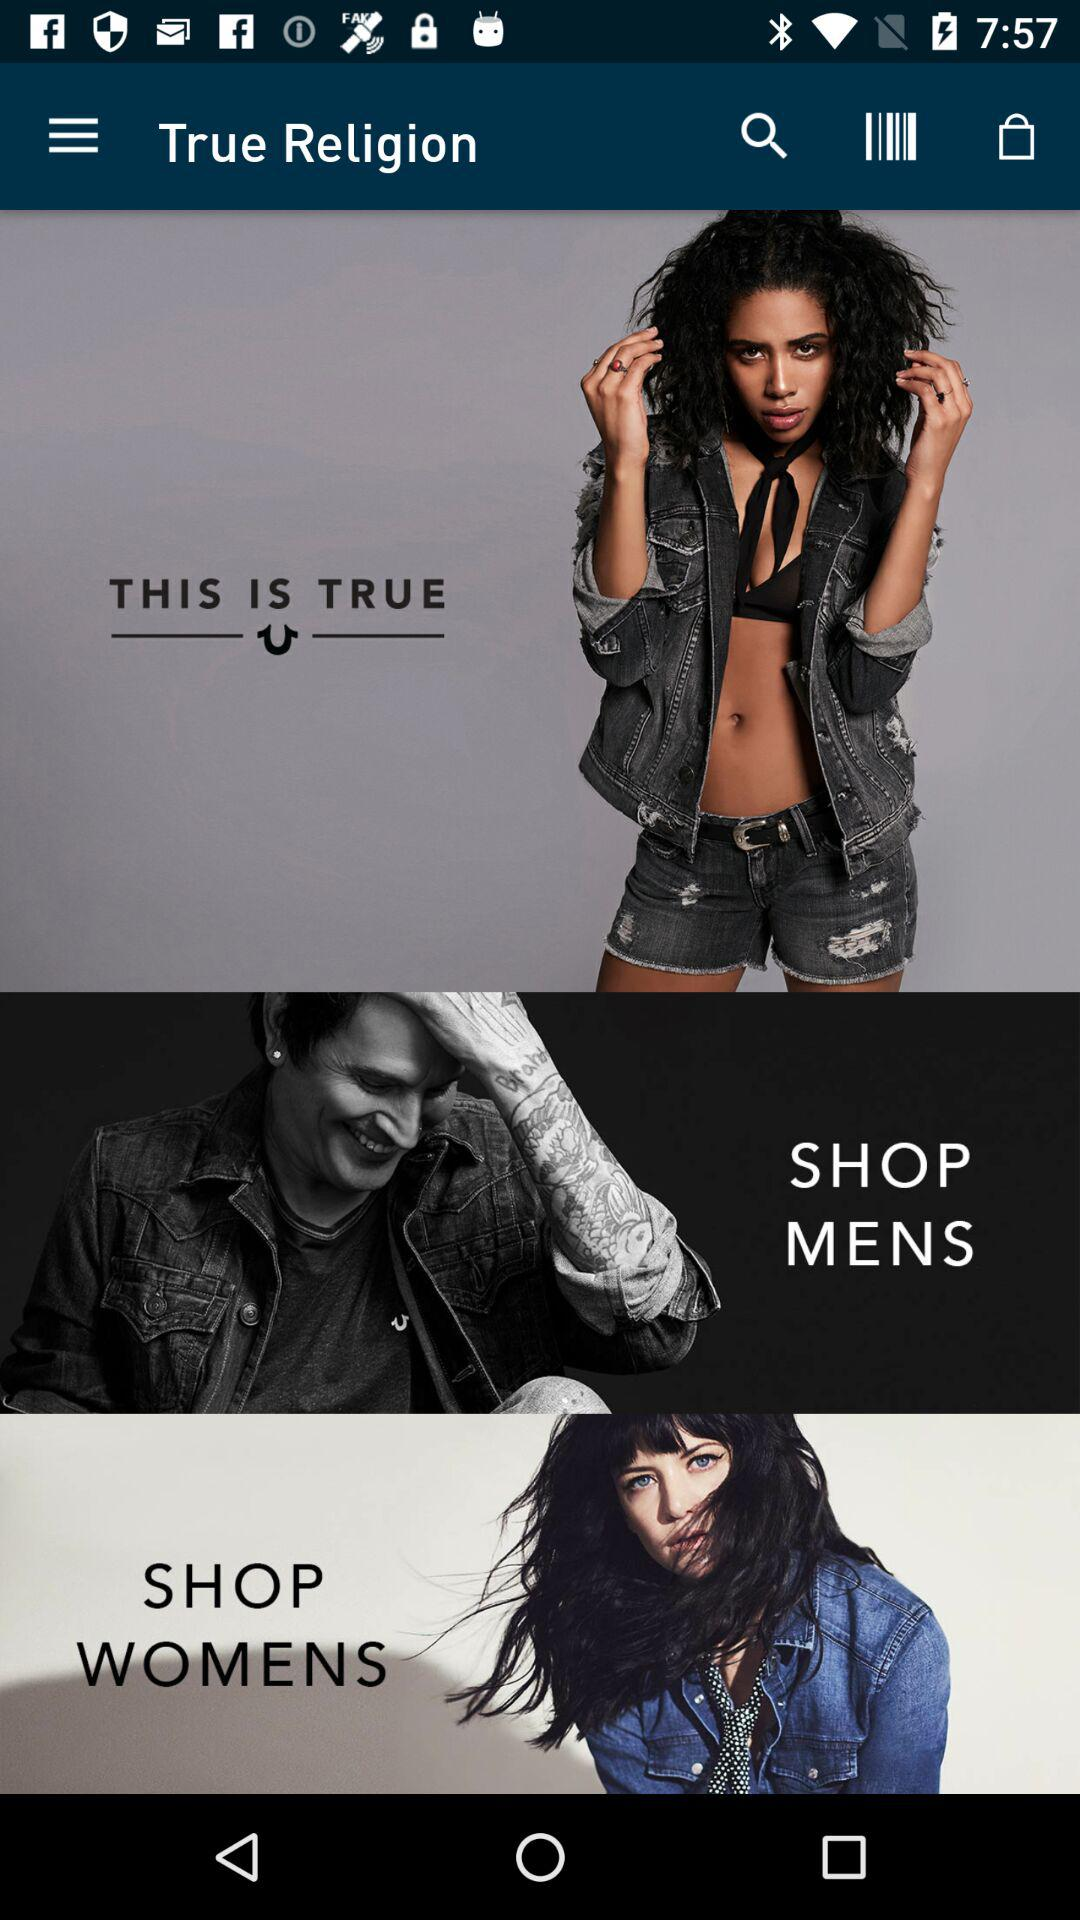What is the application name? The application name is "True Religion". 